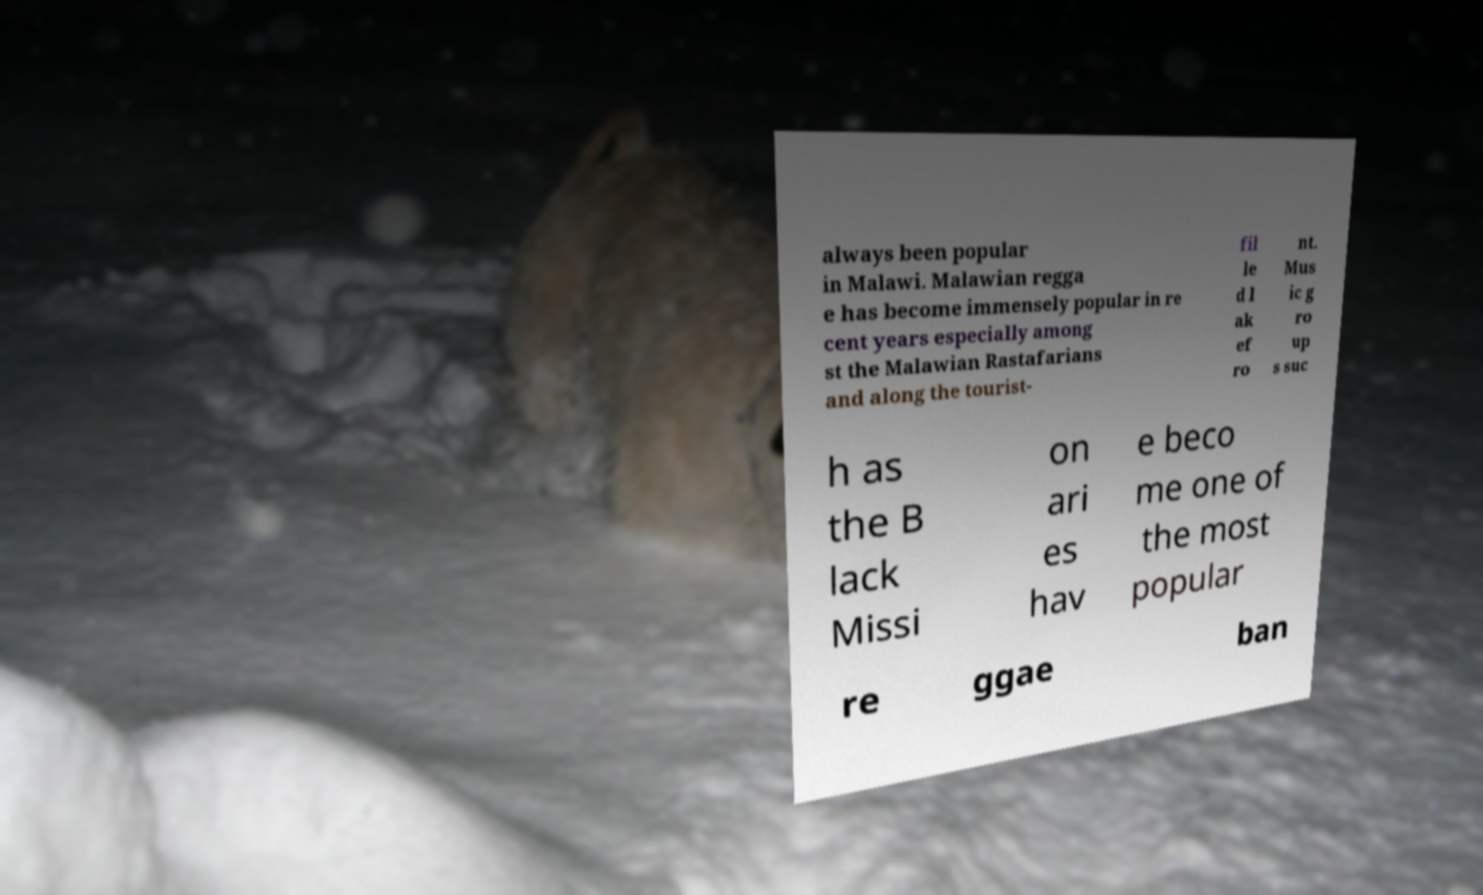Can you accurately transcribe the text from the provided image for me? always been popular in Malawi. Malawian regga e has become immensely popular in re cent years especially among st the Malawian Rastafarians and along the tourist- fil le d l ak ef ro nt. Mus ic g ro up s suc h as the B lack Missi on ari es hav e beco me one of the most popular re ggae ban 